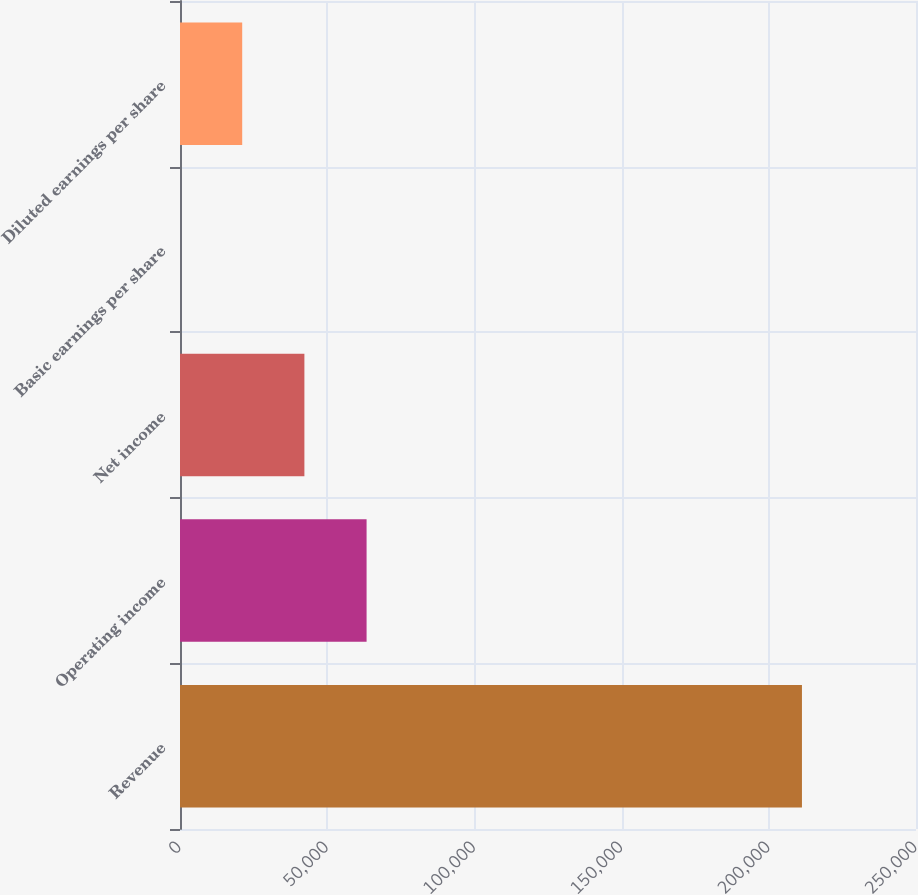Convert chart. <chart><loc_0><loc_0><loc_500><loc_500><bar_chart><fcel>Revenue<fcel>Operating income<fcel>Net income<fcel>Basic earnings per share<fcel>Diluted earnings per share<nl><fcel>211260<fcel>63378.2<fcel>42252.3<fcel>0.36<fcel>21126.3<nl></chart> 